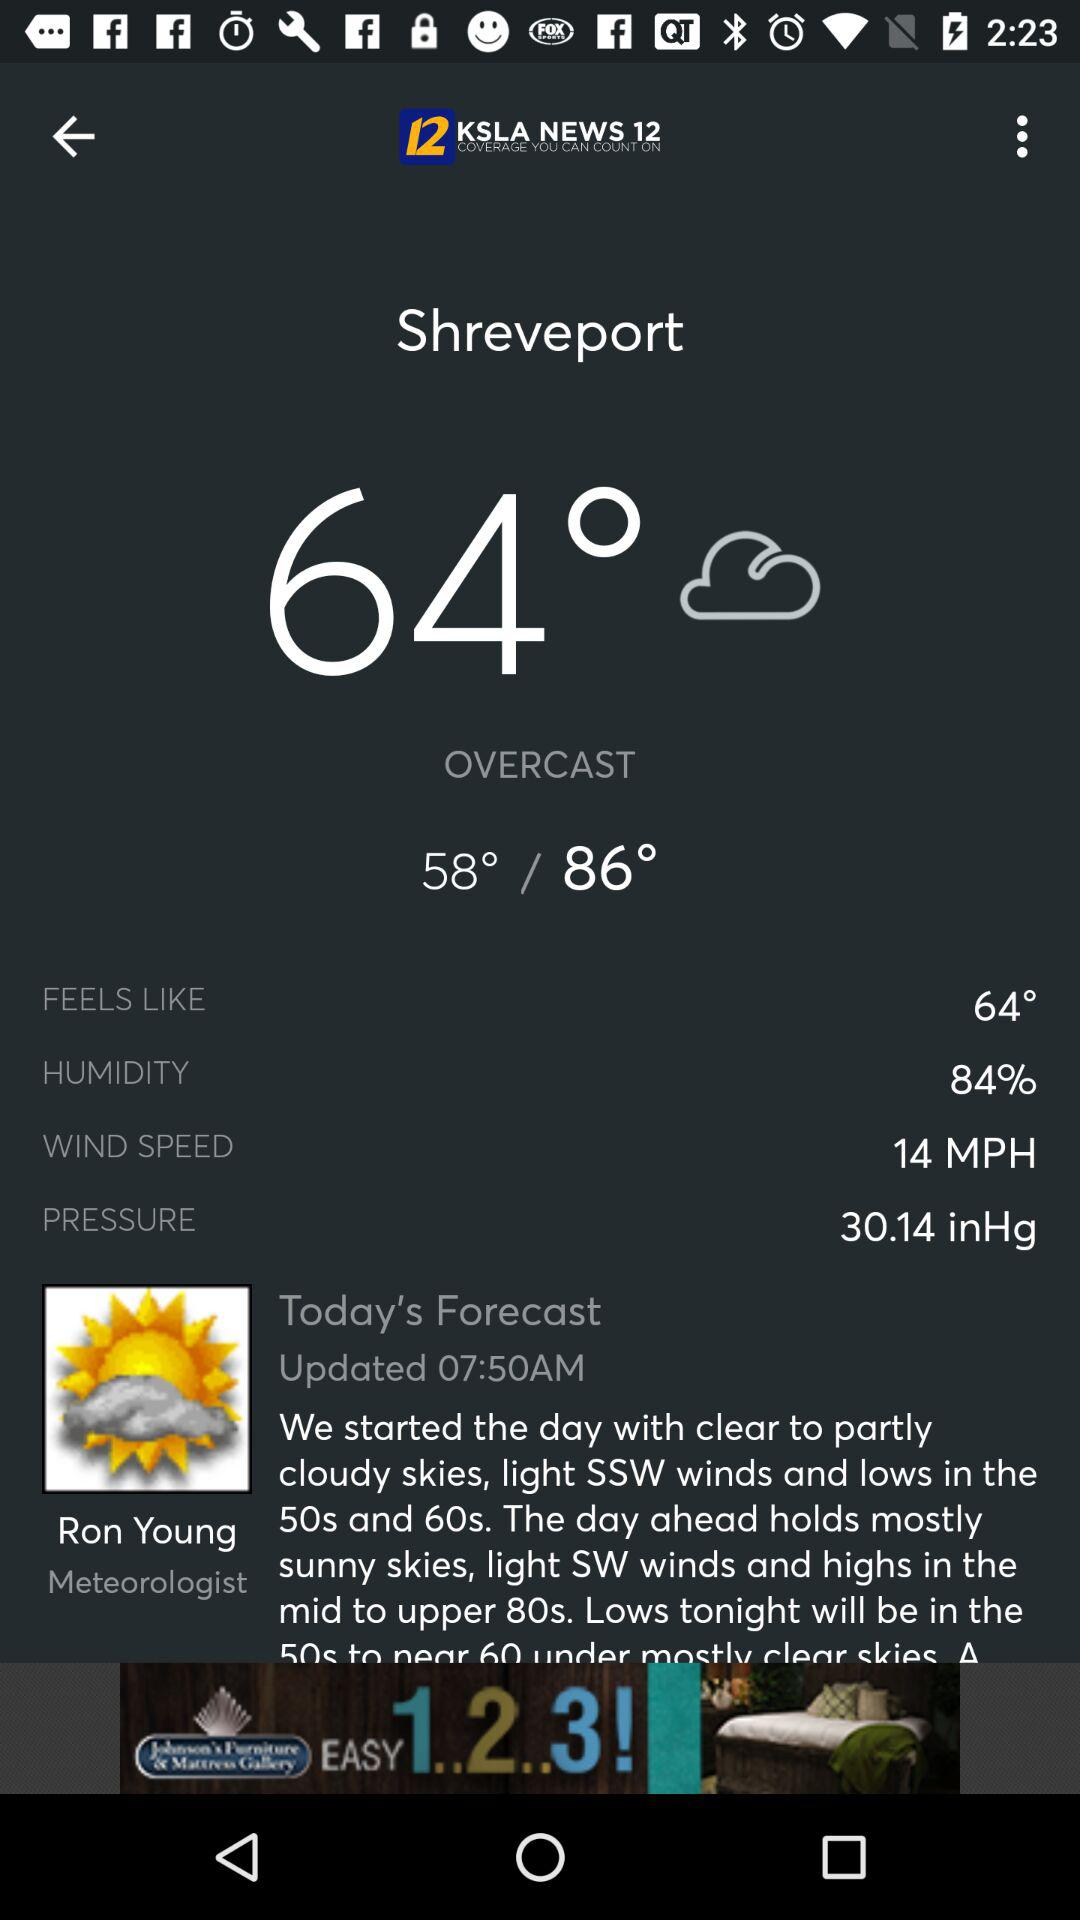What is the high temperature in degrees Fahrenheit?
Answer the question using a single word or phrase. 86° 